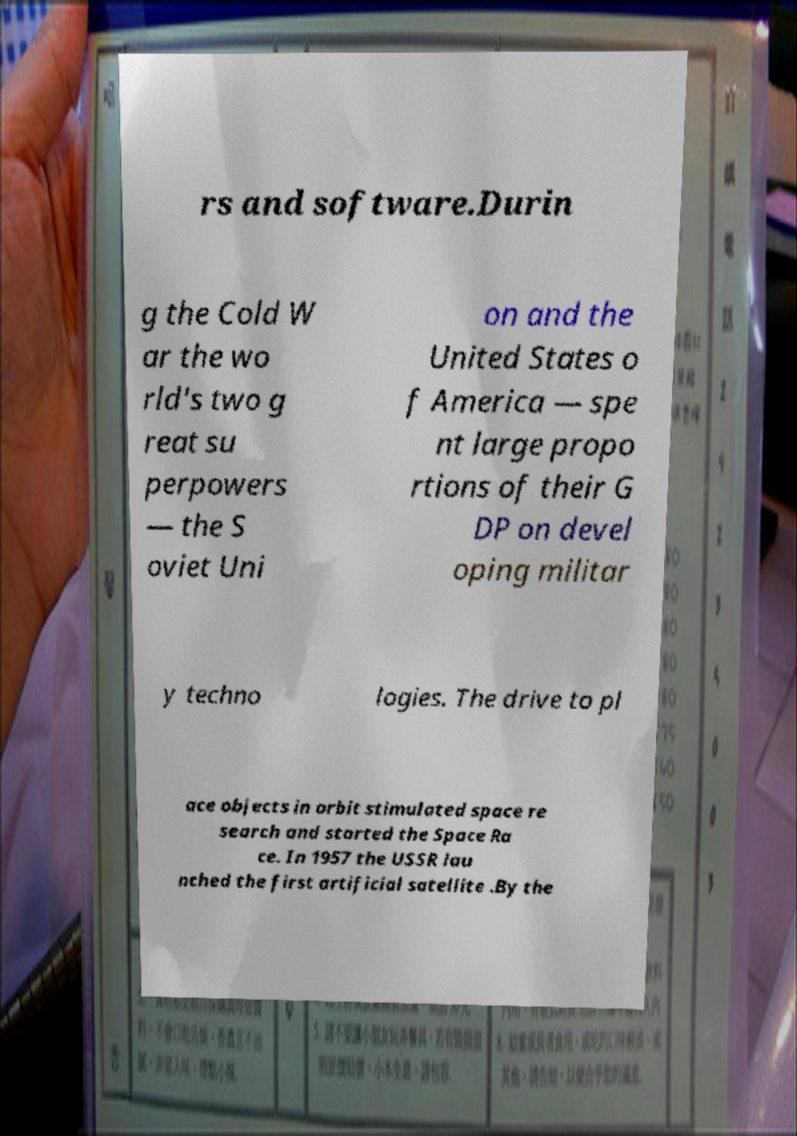Can you read and provide the text displayed in the image?This photo seems to have some interesting text. Can you extract and type it out for me? rs and software.Durin g the Cold W ar the wo rld's two g reat su perpowers — the S oviet Uni on and the United States o f America — spe nt large propo rtions of their G DP on devel oping militar y techno logies. The drive to pl ace objects in orbit stimulated space re search and started the Space Ra ce. In 1957 the USSR lau nched the first artificial satellite .By the 